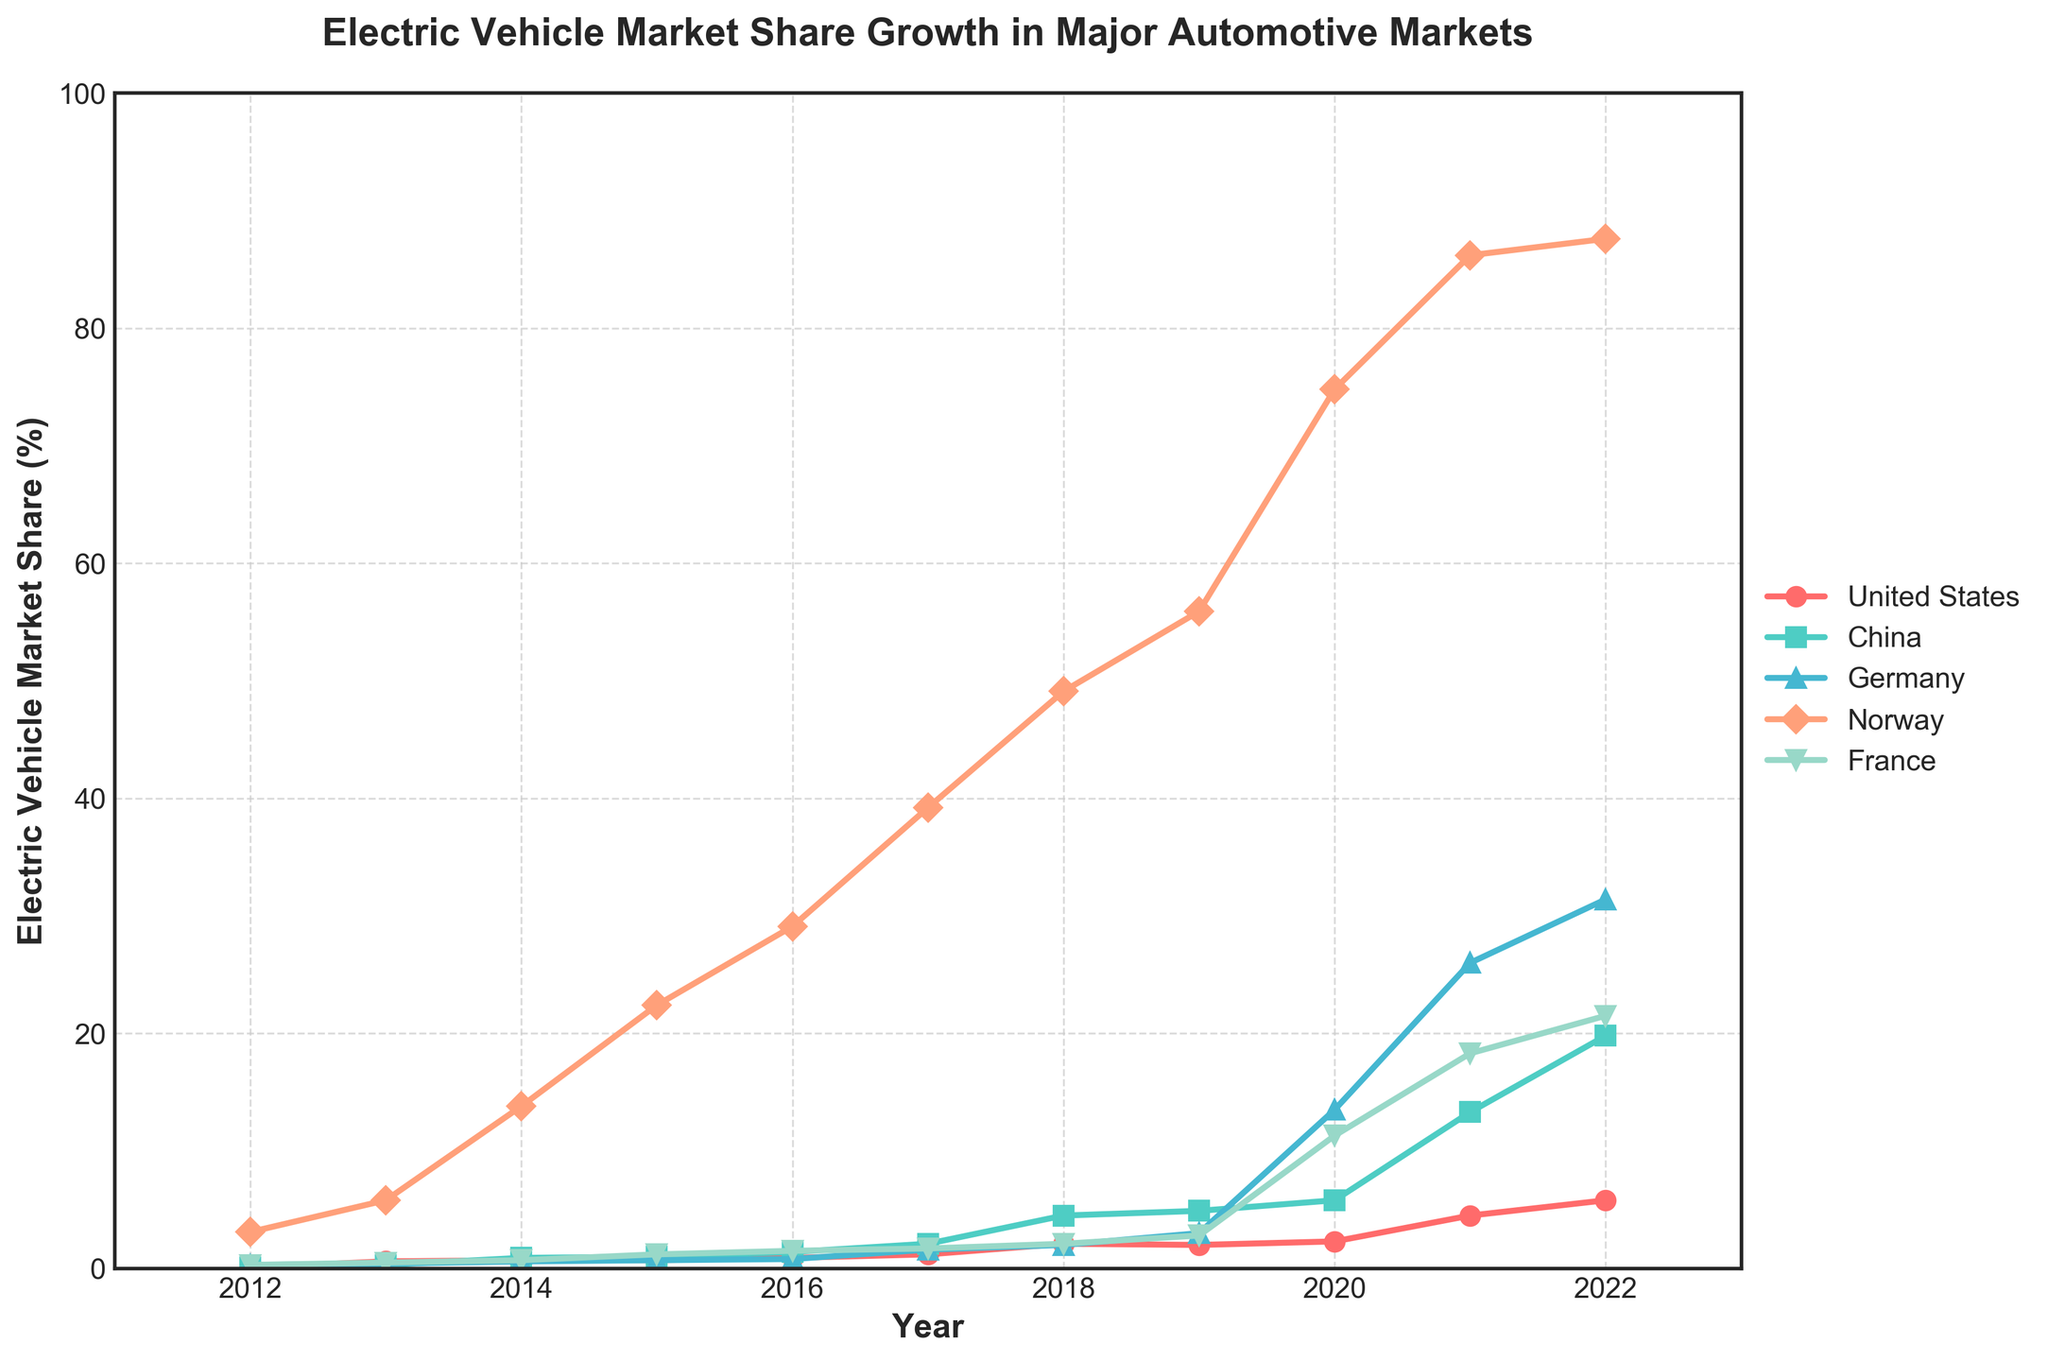Which country had the highest electric vehicle (EV) market share in 2022? From the chart, notice which country has the highest peak at the year 2022. The peak in 2022 is for Norway.
Answer: Norway How much did the EV market share in China grow from 2015 to 2022? Extract the EV market share for China for both years and compute the difference: 19.8% (2022) - 1.0% (2015).
Answer: 18.8% In which year did Germany's EV market share surpass that of the United States for the first time? Compare the marked lines for Germany and the United States and find the first year where Germany's line is above that of the United States, which is in 2017.
Answer: 2017 Which country had the most gradual increase in EV market share over the decade? Assess the slopes of the lines for each country and identify which line represents the smoothest and most gradual increase. The United States shows the most gradual increase.
Answer: United States What is the average EV market share in Norway over the years 2012-2022? Sum Norway's EV market shares for each year from 2012-2022 and divide by the number of years (sum: 3.1 + 5.8 + 13.8 + 22.4 + 29.1 + 39.2 + 49.1 + 55.9 + 74.8 + 86.2 + 87.6, count: 11).
Answer: 42.91 In which year did France see its largest yearly increase in EV market share? Look for the year-to-year difference in the EV market share in France and identify the year with the greatest increase, which is between 2019 and 2020 (from 2.8% to 11.3%).
Answer: 2020 Between 2017 and 2022, which country had the highest growth rate in EV market share percentage? Calculate the growth rate (percentage increase) over the given years for each country and compare. Norway grows from 39.2% to 87.6%: ((87.6 - 39.2) / 39.2) * 100 ≈ 123.47%; France, by comparison, grows from 1.7% to 21.5%: ((21.5 - 1.7) / 1.7) * 100 ≈ 1165%; similar calculations for other countries indicate France has the highest percentage increase.
Answer: France 